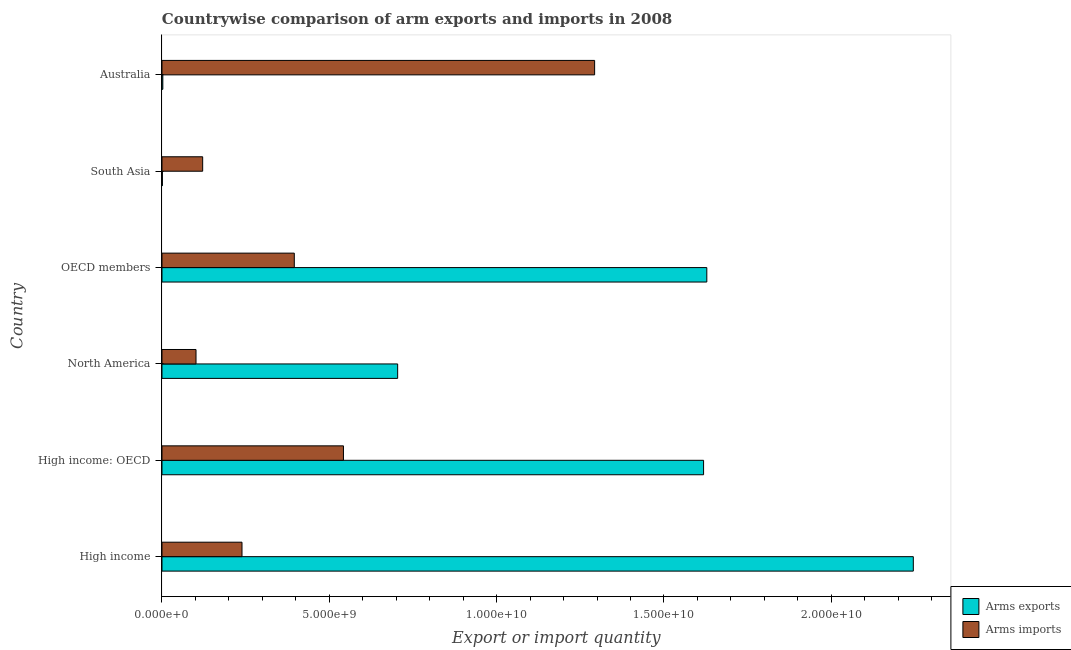How many groups of bars are there?
Ensure brevity in your answer.  6. Are the number of bars per tick equal to the number of legend labels?
Your answer should be compact. Yes. Are the number of bars on each tick of the Y-axis equal?
Keep it short and to the point. Yes. How many bars are there on the 3rd tick from the bottom?
Provide a succinct answer. 2. In how many cases, is the number of bars for a given country not equal to the number of legend labels?
Provide a short and direct response. 0. What is the arms exports in North America?
Give a very brief answer. 7.04e+09. Across all countries, what is the maximum arms imports?
Ensure brevity in your answer.  1.29e+1. Across all countries, what is the minimum arms exports?
Offer a very short reply. 1.20e+07. What is the total arms exports in the graph?
Offer a very short reply. 6.20e+1. What is the difference between the arms imports in North America and that in OECD members?
Offer a terse response. -2.94e+09. What is the difference between the arms imports in Australia and the arms exports in North America?
Make the answer very short. 5.89e+09. What is the average arms imports per country?
Give a very brief answer. 4.49e+09. What is the difference between the arms exports and arms imports in North America?
Your answer should be very brief. 6.03e+09. What is the ratio of the arms imports in North America to that in South Asia?
Your answer should be very brief. 0.84. Is the arms exports in Australia less than that in High income: OECD?
Give a very brief answer. Yes. Is the difference between the arms exports in Australia and High income greater than the difference between the arms imports in Australia and High income?
Make the answer very short. No. What is the difference between the highest and the second highest arms imports?
Offer a very short reply. 7.51e+09. What is the difference between the highest and the lowest arms imports?
Make the answer very short. 1.19e+1. Is the sum of the arms imports in Australia and High income: OECD greater than the maximum arms exports across all countries?
Give a very brief answer. No. What does the 1st bar from the top in High income represents?
Your response must be concise. Arms imports. What does the 1st bar from the bottom in South Asia represents?
Your answer should be compact. Arms exports. How many bars are there?
Your answer should be very brief. 12. Are all the bars in the graph horizontal?
Keep it short and to the point. Yes. How many countries are there in the graph?
Your response must be concise. 6. What is the difference between two consecutive major ticks on the X-axis?
Give a very brief answer. 5.00e+09. Are the values on the major ticks of X-axis written in scientific E-notation?
Ensure brevity in your answer.  Yes. Does the graph contain any zero values?
Provide a short and direct response. No. Does the graph contain grids?
Ensure brevity in your answer.  No. Where does the legend appear in the graph?
Your answer should be compact. Bottom right. How many legend labels are there?
Your answer should be very brief. 2. How are the legend labels stacked?
Provide a succinct answer. Vertical. What is the title of the graph?
Give a very brief answer. Countrywise comparison of arm exports and imports in 2008. Does "Services" appear as one of the legend labels in the graph?
Your answer should be very brief. No. What is the label or title of the X-axis?
Make the answer very short. Export or import quantity. What is the label or title of the Y-axis?
Keep it short and to the point. Country. What is the Export or import quantity of Arms exports in High income?
Offer a very short reply. 2.25e+1. What is the Export or import quantity of Arms imports in High income?
Offer a terse response. 2.39e+09. What is the Export or import quantity of Arms exports in High income: OECD?
Ensure brevity in your answer.  1.62e+1. What is the Export or import quantity of Arms imports in High income: OECD?
Make the answer very short. 5.42e+09. What is the Export or import quantity in Arms exports in North America?
Your answer should be compact. 7.04e+09. What is the Export or import quantity of Arms imports in North America?
Offer a terse response. 1.02e+09. What is the Export or import quantity in Arms exports in OECD members?
Offer a terse response. 1.63e+1. What is the Export or import quantity of Arms imports in OECD members?
Offer a terse response. 3.95e+09. What is the Export or import quantity in Arms exports in South Asia?
Provide a succinct answer. 1.20e+07. What is the Export or import quantity of Arms imports in South Asia?
Ensure brevity in your answer.  1.22e+09. What is the Export or import quantity in Arms exports in Australia?
Ensure brevity in your answer.  2.50e+07. What is the Export or import quantity of Arms imports in Australia?
Provide a short and direct response. 1.29e+1. Across all countries, what is the maximum Export or import quantity of Arms exports?
Provide a succinct answer. 2.25e+1. Across all countries, what is the maximum Export or import quantity of Arms imports?
Your answer should be compact. 1.29e+1. Across all countries, what is the minimum Export or import quantity of Arms imports?
Your answer should be very brief. 1.02e+09. What is the total Export or import quantity in Arms exports in the graph?
Your answer should be very brief. 6.20e+1. What is the total Export or import quantity in Arms imports in the graph?
Provide a short and direct response. 2.69e+1. What is the difference between the Export or import quantity of Arms exports in High income and that in High income: OECD?
Give a very brief answer. 6.27e+09. What is the difference between the Export or import quantity in Arms imports in High income and that in High income: OECD?
Offer a very short reply. -3.03e+09. What is the difference between the Export or import quantity in Arms exports in High income and that in North America?
Your answer should be compact. 1.54e+1. What is the difference between the Export or import quantity of Arms imports in High income and that in North America?
Your response must be concise. 1.37e+09. What is the difference between the Export or import quantity of Arms exports in High income and that in OECD members?
Your response must be concise. 6.17e+09. What is the difference between the Export or import quantity of Arms imports in High income and that in OECD members?
Ensure brevity in your answer.  -1.56e+09. What is the difference between the Export or import quantity of Arms exports in High income and that in South Asia?
Offer a terse response. 2.24e+1. What is the difference between the Export or import quantity of Arms imports in High income and that in South Asia?
Keep it short and to the point. 1.18e+09. What is the difference between the Export or import quantity in Arms exports in High income and that in Australia?
Offer a very short reply. 2.24e+1. What is the difference between the Export or import quantity in Arms imports in High income and that in Australia?
Provide a short and direct response. -1.05e+1. What is the difference between the Export or import quantity of Arms exports in High income: OECD and that in North America?
Your answer should be very brief. 9.14e+09. What is the difference between the Export or import quantity in Arms imports in High income: OECD and that in North America?
Provide a succinct answer. 4.41e+09. What is the difference between the Export or import quantity of Arms exports in High income: OECD and that in OECD members?
Your answer should be very brief. -9.70e+07. What is the difference between the Export or import quantity in Arms imports in High income: OECD and that in OECD members?
Your answer should be compact. 1.47e+09. What is the difference between the Export or import quantity of Arms exports in High income: OECD and that in South Asia?
Provide a short and direct response. 1.62e+1. What is the difference between the Export or import quantity of Arms imports in High income: OECD and that in South Asia?
Keep it short and to the point. 4.21e+09. What is the difference between the Export or import quantity in Arms exports in High income: OECD and that in Australia?
Give a very brief answer. 1.62e+1. What is the difference between the Export or import quantity of Arms imports in High income: OECD and that in Australia?
Ensure brevity in your answer.  -7.51e+09. What is the difference between the Export or import quantity of Arms exports in North America and that in OECD members?
Make the answer very short. -9.24e+09. What is the difference between the Export or import quantity of Arms imports in North America and that in OECD members?
Your answer should be compact. -2.94e+09. What is the difference between the Export or import quantity in Arms exports in North America and that in South Asia?
Provide a succinct answer. 7.03e+09. What is the difference between the Export or import quantity in Arms imports in North America and that in South Asia?
Your answer should be very brief. -1.99e+08. What is the difference between the Export or import quantity of Arms exports in North America and that in Australia?
Your answer should be very brief. 7.02e+09. What is the difference between the Export or import quantity of Arms imports in North America and that in Australia?
Offer a terse response. -1.19e+1. What is the difference between the Export or import quantity in Arms exports in OECD members and that in South Asia?
Ensure brevity in your answer.  1.63e+1. What is the difference between the Export or import quantity of Arms imports in OECD members and that in South Asia?
Provide a short and direct response. 2.74e+09. What is the difference between the Export or import quantity in Arms exports in OECD members and that in Australia?
Provide a short and direct response. 1.63e+1. What is the difference between the Export or import quantity of Arms imports in OECD members and that in Australia?
Provide a short and direct response. -8.98e+09. What is the difference between the Export or import quantity of Arms exports in South Asia and that in Australia?
Ensure brevity in your answer.  -1.30e+07. What is the difference between the Export or import quantity in Arms imports in South Asia and that in Australia?
Provide a short and direct response. -1.17e+1. What is the difference between the Export or import quantity of Arms exports in High income and the Export or import quantity of Arms imports in High income: OECD?
Your answer should be very brief. 1.70e+1. What is the difference between the Export or import quantity in Arms exports in High income and the Export or import quantity in Arms imports in North America?
Your answer should be compact. 2.14e+1. What is the difference between the Export or import quantity of Arms exports in High income and the Export or import quantity of Arms imports in OECD members?
Ensure brevity in your answer.  1.85e+1. What is the difference between the Export or import quantity of Arms exports in High income and the Export or import quantity of Arms imports in South Asia?
Give a very brief answer. 2.12e+1. What is the difference between the Export or import quantity of Arms exports in High income and the Export or import quantity of Arms imports in Australia?
Your answer should be very brief. 9.52e+09. What is the difference between the Export or import quantity of Arms exports in High income: OECD and the Export or import quantity of Arms imports in North America?
Make the answer very short. 1.52e+1. What is the difference between the Export or import quantity of Arms exports in High income: OECD and the Export or import quantity of Arms imports in OECD members?
Give a very brief answer. 1.22e+1. What is the difference between the Export or import quantity of Arms exports in High income: OECD and the Export or import quantity of Arms imports in South Asia?
Give a very brief answer. 1.50e+1. What is the difference between the Export or import quantity of Arms exports in High income: OECD and the Export or import quantity of Arms imports in Australia?
Ensure brevity in your answer.  3.26e+09. What is the difference between the Export or import quantity in Arms exports in North America and the Export or import quantity in Arms imports in OECD members?
Provide a succinct answer. 3.09e+09. What is the difference between the Export or import quantity in Arms exports in North America and the Export or import quantity in Arms imports in South Asia?
Make the answer very short. 5.83e+09. What is the difference between the Export or import quantity in Arms exports in North America and the Export or import quantity in Arms imports in Australia?
Your answer should be very brief. -5.89e+09. What is the difference between the Export or import quantity of Arms exports in OECD members and the Export or import quantity of Arms imports in South Asia?
Provide a short and direct response. 1.51e+1. What is the difference between the Export or import quantity in Arms exports in OECD members and the Export or import quantity in Arms imports in Australia?
Make the answer very short. 3.35e+09. What is the difference between the Export or import quantity in Arms exports in South Asia and the Export or import quantity in Arms imports in Australia?
Provide a short and direct response. -1.29e+1. What is the average Export or import quantity of Arms exports per country?
Offer a terse response. 1.03e+1. What is the average Export or import quantity in Arms imports per country?
Your answer should be very brief. 4.49e+09. What is the difference between the Export or import quantity in Arms exports and Export or import quantity in Arms imports in High income?
Give a very brief answer. 2.01e+1. What is the difference between the Export or import quantity in Arms exports and Export or import quantity in Arms imports in High income: OECD?
Provide a short and direct response. 1.08e+1. What is the difference between the Export or import quantity of Arms exports and Export or import quantity of Arms imports in North America?
Make the answer very short. 6.03e+09. What is the difference between the Export or import quantity in Arms exports and Export or import quantity in Arms imports in OECD members?
Your answer should be very brief. 1.23e+1. What is the difference between the Export or import quantity of Arms exports and Export or import quantity of Arms imports in South Asia?
Provide a succinct answer. -1.20e+09. What is the difference between the Export or import quantity of Arms exports and Export or import quantity of Arms imports in Australia?
Provide a short and direct response. -1.29e+1. What is the ratio of the Export or import quantity in Arms exports in High income to that in High income: OECD?
Provide a short and direct response. 1.39. What is the ratio of the Export or import quantity in Arms imports in High income to that in High income: OECD?
Ensure brevity in your answer.  0.44. What is the ratio of the Export or import quantity of Arms exports in High income to that in North America?
Your answer should be compact. 3.19. What is the ratio of the Export or import quantity of Arms imports in High income to that in North America?
Your answer should be very brief. 2.35. What is the ratio of the Export or import quantity in Arms exports in High income to that in OECD members?
Your answer should be very brief. 1.38. What is the ratio of the Export or import quantity of Arms imports in High income to that in OECD members?
Your answer should be very brief. 0.6. What is the ratio of the Export or import quantity of Arms exports in High income to that in South Asia?
Ensure brevity in your answer.  1871.08. What is the ratio of the Export or import quantity of Arms imports in High income to that in South Asia?
Your answer should be very brief. 1.97. What is the ratio of the Export or import quantity of Arms exports in High income to that in Australia?
Give a very brief answer. 898.12. What is the ratio of the Export or import quantity of Arms imports in High income to that in Australia?
Offer a terse response. 0.18. What is the ratio of the Export or import quantity of Arms exports in High income: OECD to that in North America?
Your response must be concise. 2.3. What is the ratio of the Export or import quantity in Arms imports in High income: OECD to that in North America?
Keep it short and to the point. 5.33. What is the ratio of the Export or import quantity of Arms exports in High income: OECD to that in OECD members?
Give a very brief answer. 0.99. What is the ratio of the Export or import quantity of Arms imports in High income: OECD to that in OECD members?
Your answer should be compact. 1.37. What is the ratio of the Export or import quantity of Arms exports in High income: OECD to that in South Asia?
Make the answer very short. 1348.75. What is the ratio of the Export or import quantity of Arms imports in High income: OECD to that in South Asia?
Make the answer very short. 4.46. What is the ratio of the Export or import quantity in Arms exports in High income: OECD to that in Australia?
Your response must be concise. 647.4. What is the ratio of the Export or import quantity of Arms imports in High income: OECD to that in Australia?
Offer a terse response. 0.42. What is the ratio of the Export or import quantity of Arms exports in North America to that in OECD members?
Your answer should be compact. 0.43. What is the ratio of the Export or import quantity of Arms imports in North America to that in OECD members?
Give a very brief answer. 0.26. What is the ratio of the Export or import quantity in Arms exports in North America to that in South Asia?
Offer a terse response. 586.92. What is the ratio of the Export or import quantity in Arms imports in North America to that in South Asia?
Ensure brevity in your answer.  0.84. What is the ratio of the Export or import quantity in Arms exports in North America to that in Australia?
Your answer should be compact. 281.72. What is the ratio of the Export or import quantity of Arms imports in North America to that in Australia?
Keep it short and to the point. 0.08. What is the ratio of the Export or import quantity of Arms exports in OECD members to that in South Asia?
Your response must be concise. 1356.83. What is the ratio of the Export or import quantity of Arms imports in OECD members to that in South Asia?
Your answer should be compact. 3.25. What is the ratio of the Export or import quantity of Arms exports in OECD members to that in Australia?
Provide a succinct answer. 651.28. What is the ratio of the Export or import quantity of Arms imports in OECD members to that in Australia?
Offer a very short reply. 0.31. What is the ratio of the Export or import quantity in Arms exports in South Asia to that in Australia?
Make the answer very short. 0.48. What is the ratio of the Export or import quantity of Arms imports in South Asia to that in Australia?
Offer a terse response. 0.09. What is the difference between the highest and the second highest Export or import quantity in Arms exports?
Make the answer very short. 6.17e+09. What is the difference between the highest and the second highest Export or import quantity in Arms imports?
Give a very brief answer. 7.51e+09. What is the difference between the highest and the lowest Export or import quantity of Arms exports?
Ensure brevity in your answer.  2.24e+1. What is the difference between the highest and the lowest Export or import quantity in Arms imports?
Provide a succinct answer. 1.19e+1. 